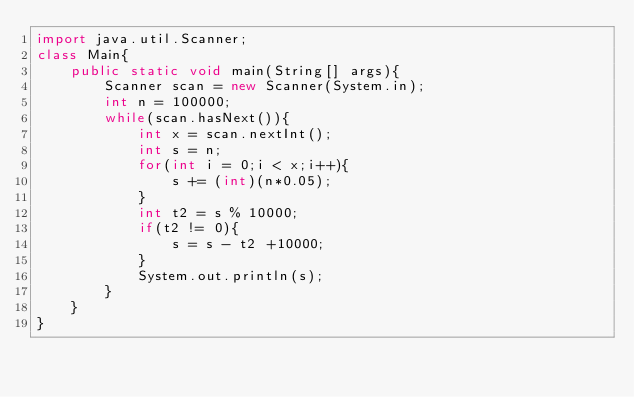Convert code to text. <code><loc_0><loc_0><loc_500><loc_500><_Java_>import java.util.Scanner;
class Main{
	public static void main(String[] args){
		Scanner scan = new Scanner(System.in);
		int n = 100000;
		while(scan.hasNext()){
			int x = scan.nextInt();
			int s = n;
			for(int i = 0;i < x;i++){
				s += (int)(n*0.05);
			}
			int t2 = s % 10000;
			if(t2 != 0){
				s = s - t2 +10000;
			}
			System.out.println(s);
		}
	}
}</code> 